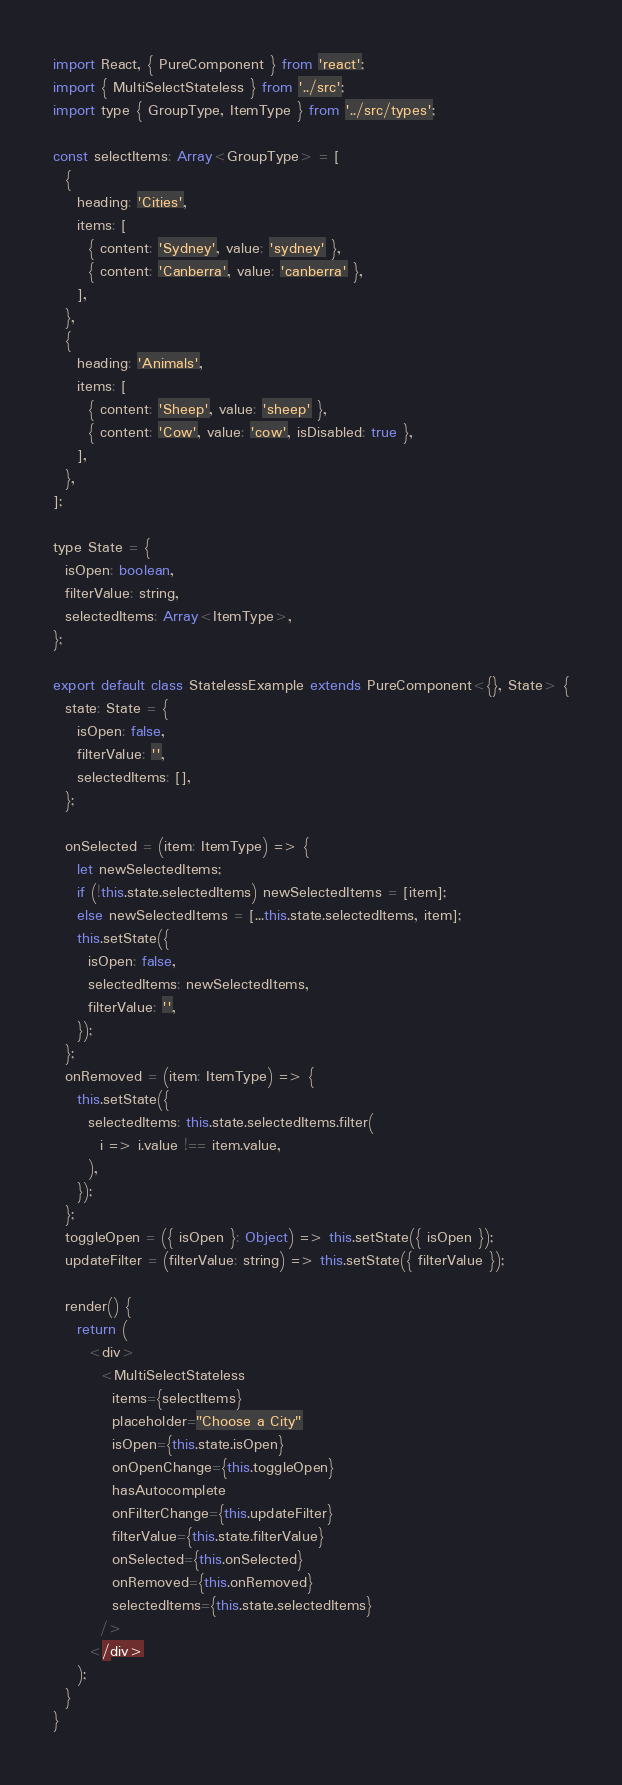Convert code to text. <code><loc_0><loc_0><loc_500><loc_500><_JavaScript_>import React, { PureComponent } from 'react';
import { MultiSelectStateless } from '../src';
import type { GroupType, ItemType } from '../src/types';

const selectItems: Array<GroupType> = [
  {
    heading: 'Cities',
    items: [
      { content: 'Sydney', value: 'sydney' },
      { content: 'Canberra', value: 'canberra' },
    ],
  },
  {
    heading: 'Animals',
    items: [
      { content: 'Sheep', value: 'sheep' },
      { content: 'Cow', value: 'cow', isDisabled: true },
    ],
  },
];

type State = {
  isOpen: boolean,
  filterValue: string,
  selectedItems: Array<ItemType>,
};

export default class StatelessExample extends PureComponent<{}, State> {
  state: State = {
    isOpen: false,
    filterValue: '',
    selectedItems: [],
  };

  onSelected = (item: ItemType) => {
    let newSelectedItems;
    if (!this.state.selectedItems) newSelectedItems = [item];
    else newSelectedItems = [...this.state.selectedItems, item];
    this.setState({
      isOpen: false,
      selectedItems: newSelectedItems,
      filterValue: '',
    });
  };
  onRemoved = (item: ItemType) => {
    this.setState({
      selectedItems: this.state.selectedItems.filter(
        i => i.value !== item.value,
      ),
    });
  };
  toggleOpen = ({ isOpen }: Object) => this.setState({ isOpen });
  updateFilter = (filterValue: string) => this.setState({ filterValue });

  render() {
    return (
      <div>
        <MultiSelectStateless
          items={selectItems}
          placeholder="Choose a City"
          isOpen={this.state.isOpen}
          onOpenChange={this.toggleOpen}
          hasAutocomplete
          onFilterChange={this.updateFilter}
          filterValue={this.state.filterValue}
          onSelected={this.onSelected}
          onRemoved={this.onRemoved}
          selectedItems={this.state.selectedItems}
        />
      </div>
    );
  }
}
</code> 